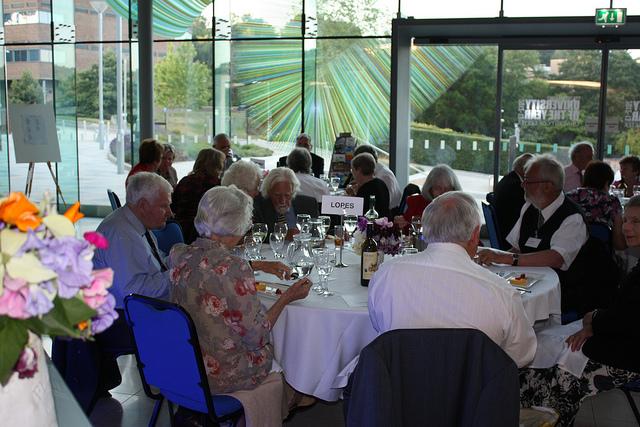Are they enjoying themselves?
Short answer required. Yes. Are there flowers in the photo?
Write a very short answer. Yes. What are the people sitting around?
Give a very brief answer. Table. 